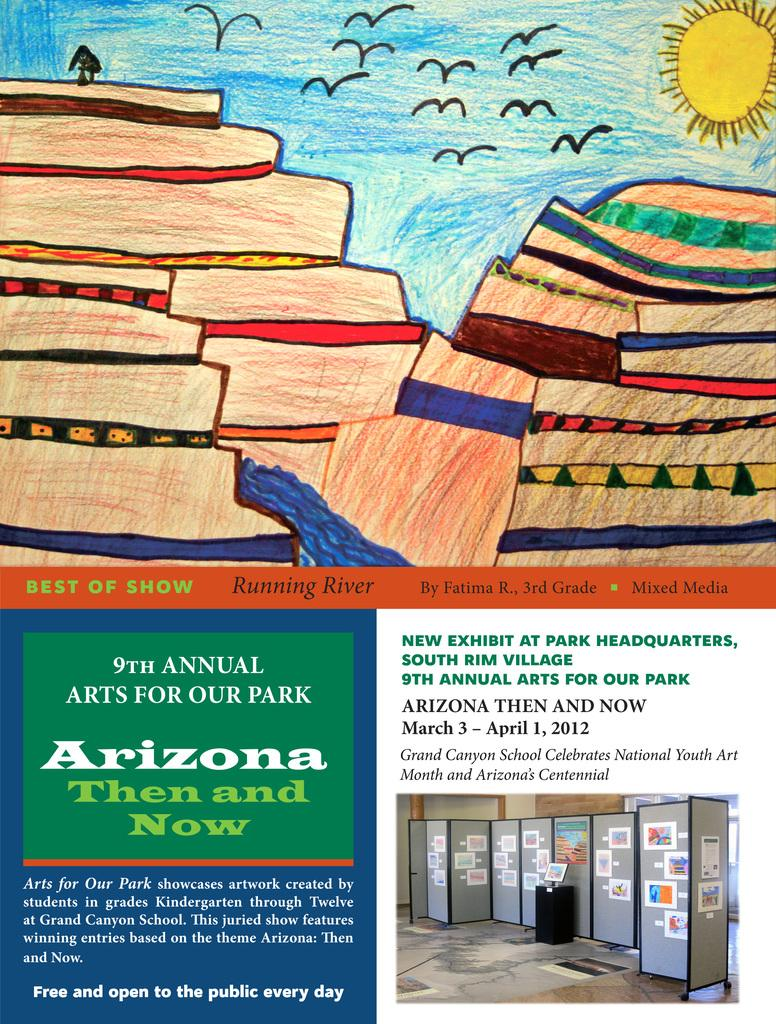<image>
Describe the image concisely. A poster for the 9th annual arts for our park festival. 